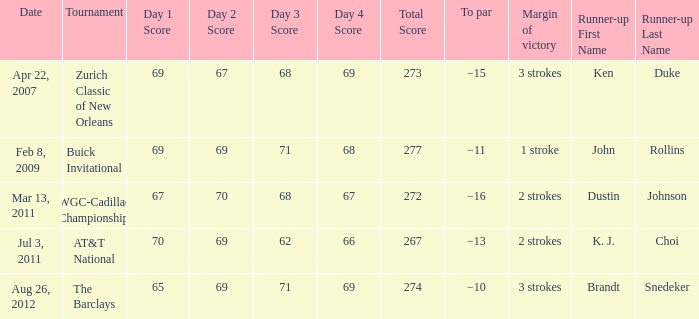On what date does a tournament have a 2-stroke victory margin and a par of -16? Mar 13, 2011. 